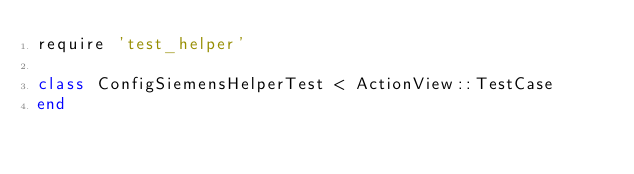Convert code to text. <code><loc_0><loc_0><loc_500><loc_500><_Ruby_>require 'test_helper'

class ConfigSiemensHelperTest < ActionView::TestCase
end
</code> 